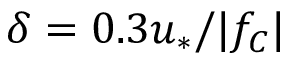<formula> <loc_0><loc_0><loc_500><loc_500>\delta = 0 . 3 u _ { \ast } / | f _ { C } |</formula> 